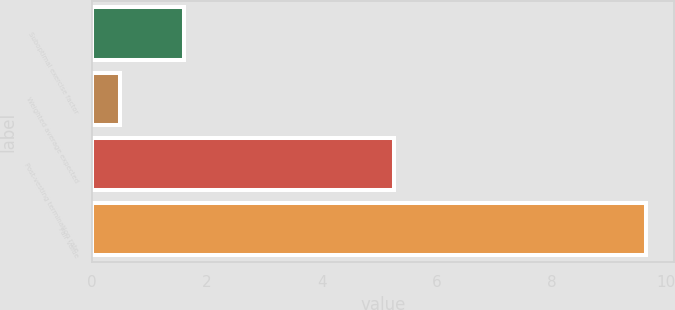<chart> <loc_0><loc_0><loc_500><loc_500><bar_chart><fcel>Suboptimal exercise factor<fcel>Weighted average expected<fcel>Post-vesting termination rate<fcel>Fair value<nl><fcel>1.61<fcel>0.48<fcel>5.26<fcel>9.65<nl></chart> 